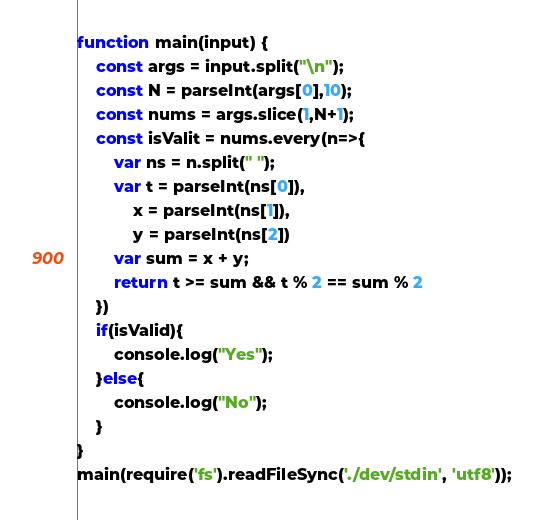<code> <loc_0><loc_0><loc_500><loc_500><_JavaScript_>function main(input) {
    const args = input.split("\n");
    const N = parseInt(args[0],10);
    const nums = args.slice(1,N+1);
    const isValit = nums.every(n=>{
        var ns = n.split(" ");
        var t = parseInt(ns[0]),
            x = parseInt(ns[1]),
            y = parseInt(ns[2])
        var sum = x + y;
        return t >= sum && t % 2 == sum % 2
    })
    if(isValid){
        console.log("Yes");
    }else{
        console.log("No");
    }
}
main(require('fs').readFileSync('./dev/stdin', 'utf8'));</code> 